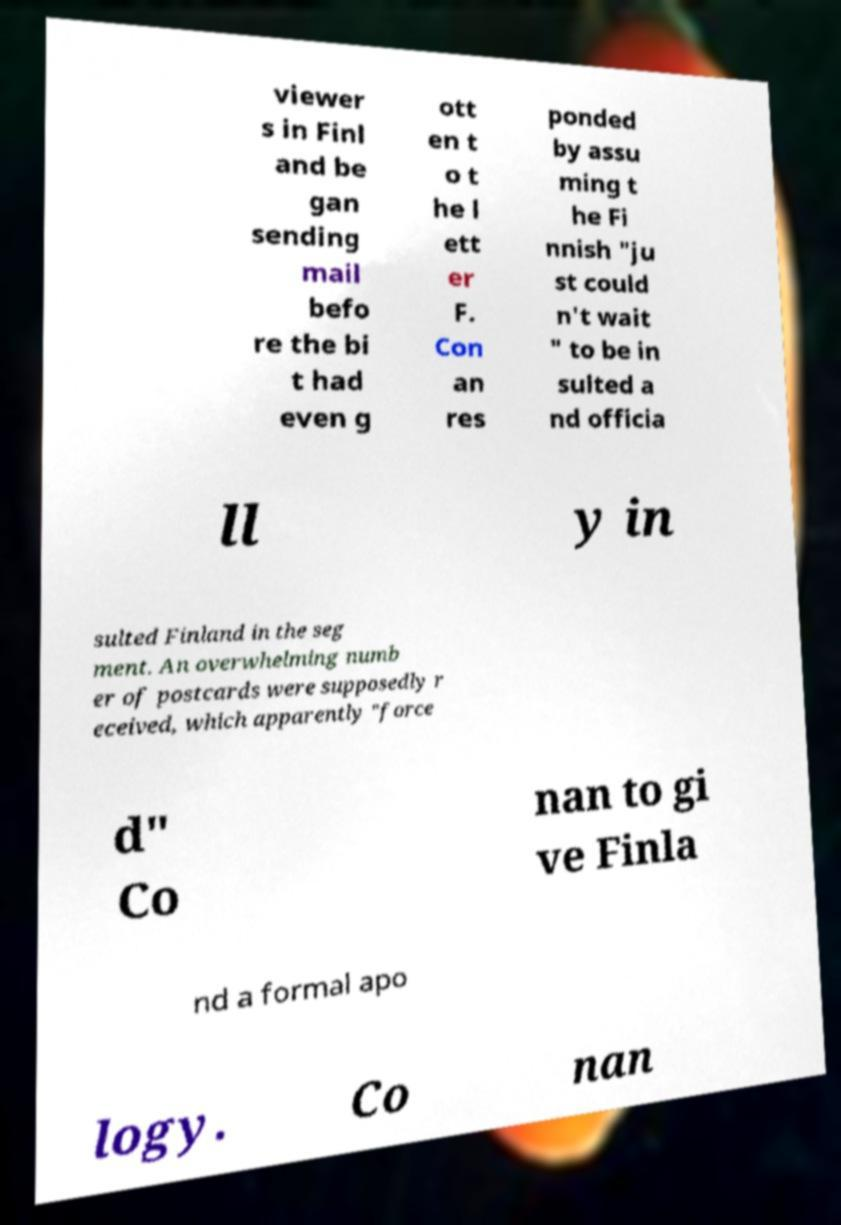Please read and relay the text visible in this image. What does it say? viewer s in Finl and be gan sending mail befo re the bi t had even g ott en t o t he l ett er F. Con an res ponded by assu ming t he Fi nnish "ju st could n't wait " to be in sulted a nd officia ll y in sulted Finland in the seg ment. An overwhelming numb er of postcards were supposedly r eceived, which apparently "force d" Co nan to gi ve Finla nd a formal apo logy. Co nan 